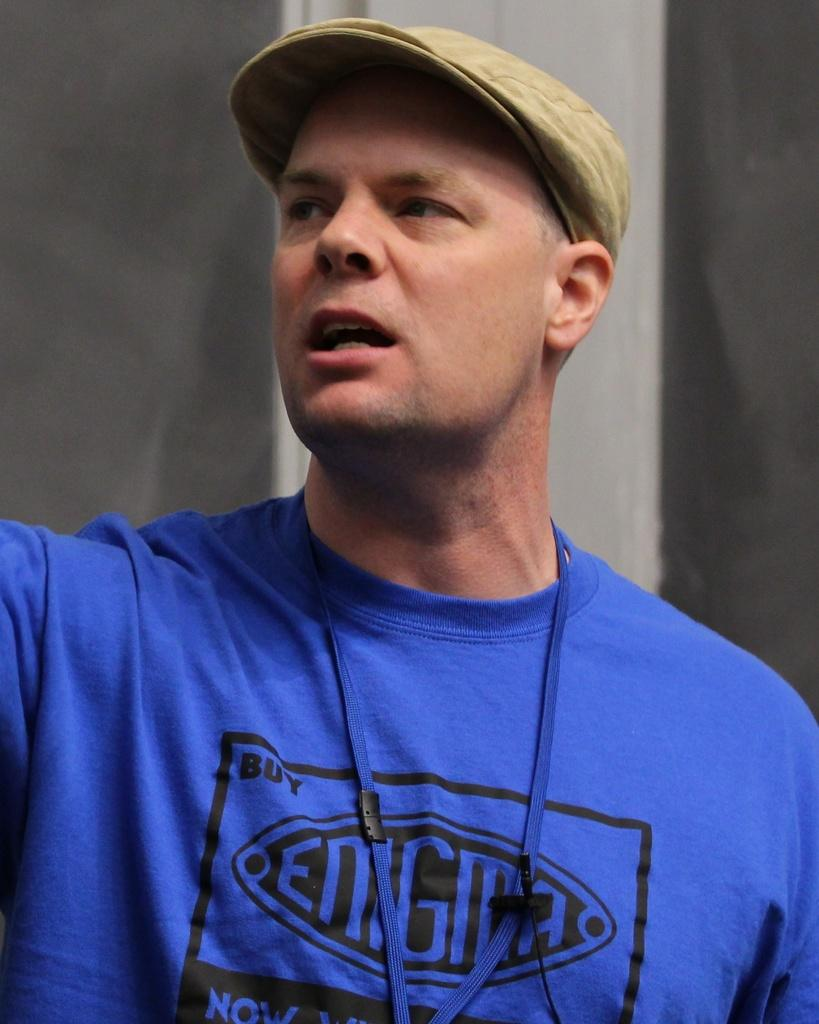<image>
Offer a succinct explanation of the picture presented. Male speaker in a blue shirt that is reading Enigma 